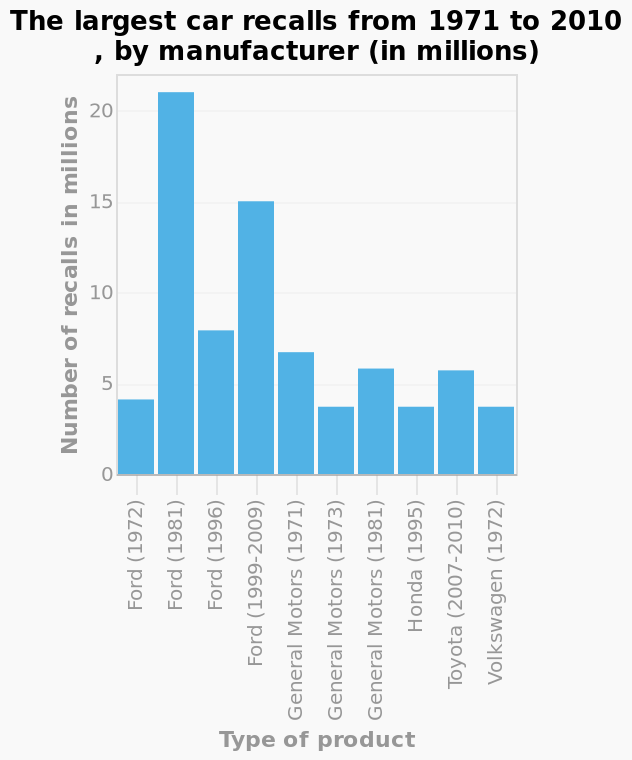<image>
What were the years of the two largest recalls for Ford? 1981 and 1999-2009 Which companies had the least amount of recalls? Volkswagen in 1972 What is the title of the bar diagram? The largest car recalls from 1971 to 2010, by manufacturer (in millions) 